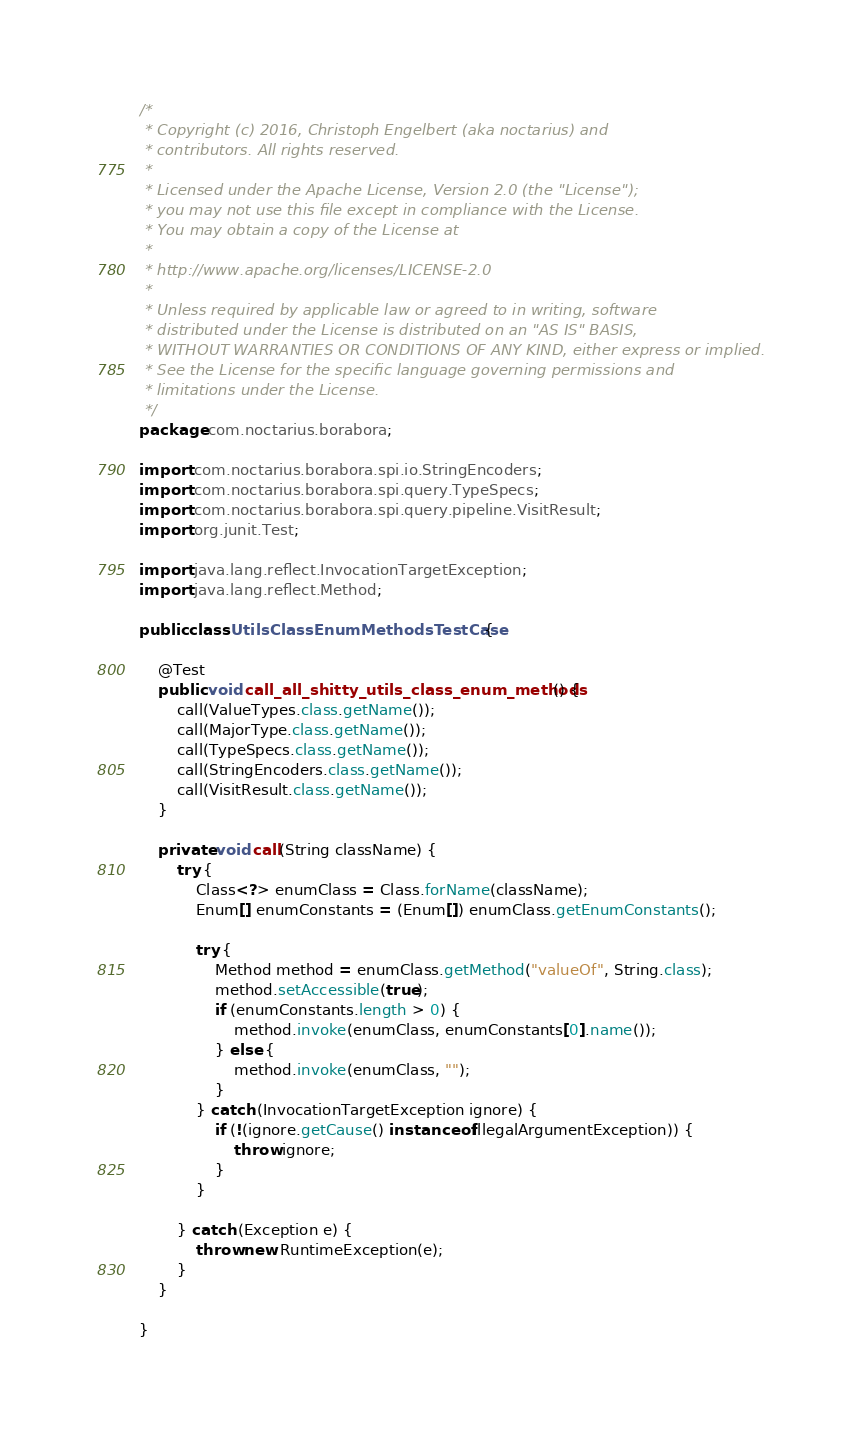Convert code to text. <code><loc_0><loc_0><loc_500><loc_500><_Java_>/*
 * Copyright (c) 2016, Christoph Engelbert (aka noctarius) and
 * contributors. All rights reserved.
 *
 * Licensed under the Apache License, Version 2.0 (the "License");
 * you may not use this file except in compliance with the License.
 * You may obtain a copy of the License at
 *
 * http://www.apache.org/licenses/LICENSE-2.0
 *
 * Unless required by applicable law or agreed to in writing, software
 * distributed under the License is distributed on an "AS IS" BASIS,
 * WITHOUT WARRANTIES OR CONDITIONS OF ANY KIND, either express or implied.
 * See the License for the specific language governing permissions and
 * limitations under the License.
 */
package com.noctarius.borabora;

import com.noctarius.borabora.spi.io.StringEncoders;
import com.noctarius.borabora.spi.query.TypeSpecs;
import com.noctarius.borabora.spi.query.pipeline.VisitResult;
import org.junit.Test;

import java.lang.reflect.InvocationTargetException;
import java.lang.reflect.Method;

public class UtilsClassEnumMethodsTestCase {

    @Test
    public void call_all_shitty_utils_class_enum_methods() {
        call(ValueTypes.class.getName());
        call(MajorType.class.getName());
        call(TypeSpecs.class.getName());
        call(StringEncoders.class.getName());
        call(VisitResult.class.getName());
    }

    private void call(String className) {
        try {
            Class<?> enumClass = Class.forName(className);
            Enum[] enumConstants = (Enum[]) enumClass.getEnumConstants();

            try {
                Method method = enumClass.getMethod("valueOf", String.class);
                method.setAccessible(true);
                if (enumConstants.length > 0) {
                    method.invoke(enumClass, enumConstants[0].name());
                } else {
                    method.invoke(enumClass, "");
                }
            } catch (InvocationTargetException ignore) {
                if (!(ignore.getCause() instanceof IllegalArgumentException)) {
                    throw ignore;
                }
            }

        } catch (Exception e) {
            throw new RuntimeException(e);
        }
    }

}
</code> 